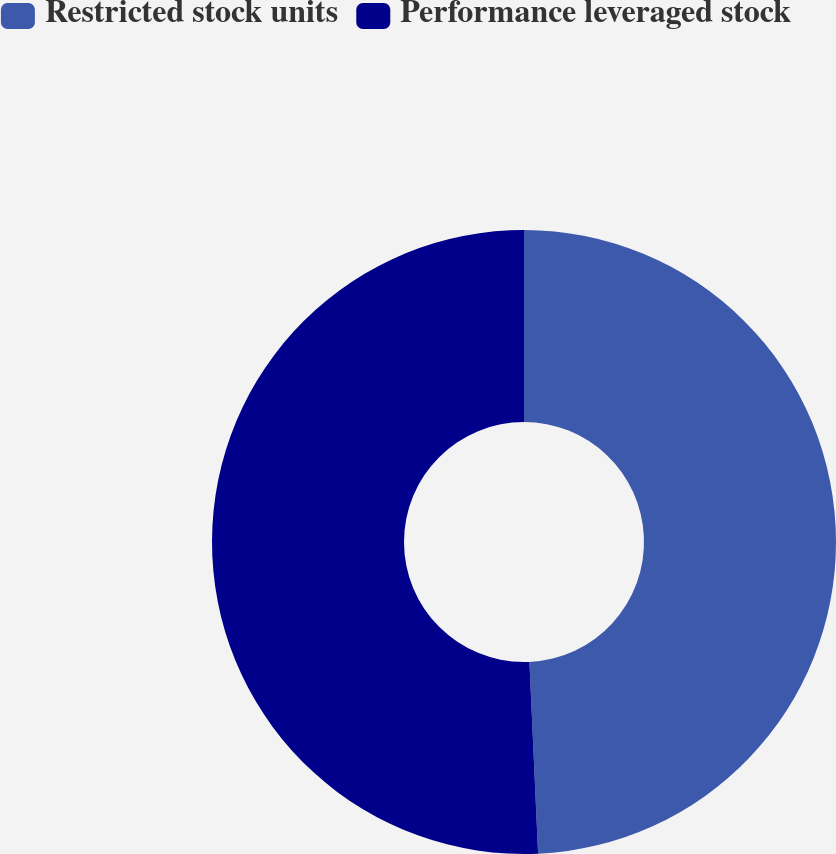Convert chart. <chart><loc_0><loc_0><loc_500><loc_500><pie_chart><fcel>Restricted stock units<fcel>Performance leveraged stock<nl><fcel>49.28%<fcel>50.72%<nl></chart> 